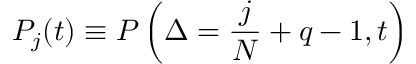Convert formula to latex. <formula><loc_0><loc_0><loc_500><loc_500>P _ { j } ( t ) \equiv P \left ( \Delta = \frac { j } { N } + q - 1 , t \right )</formula> 